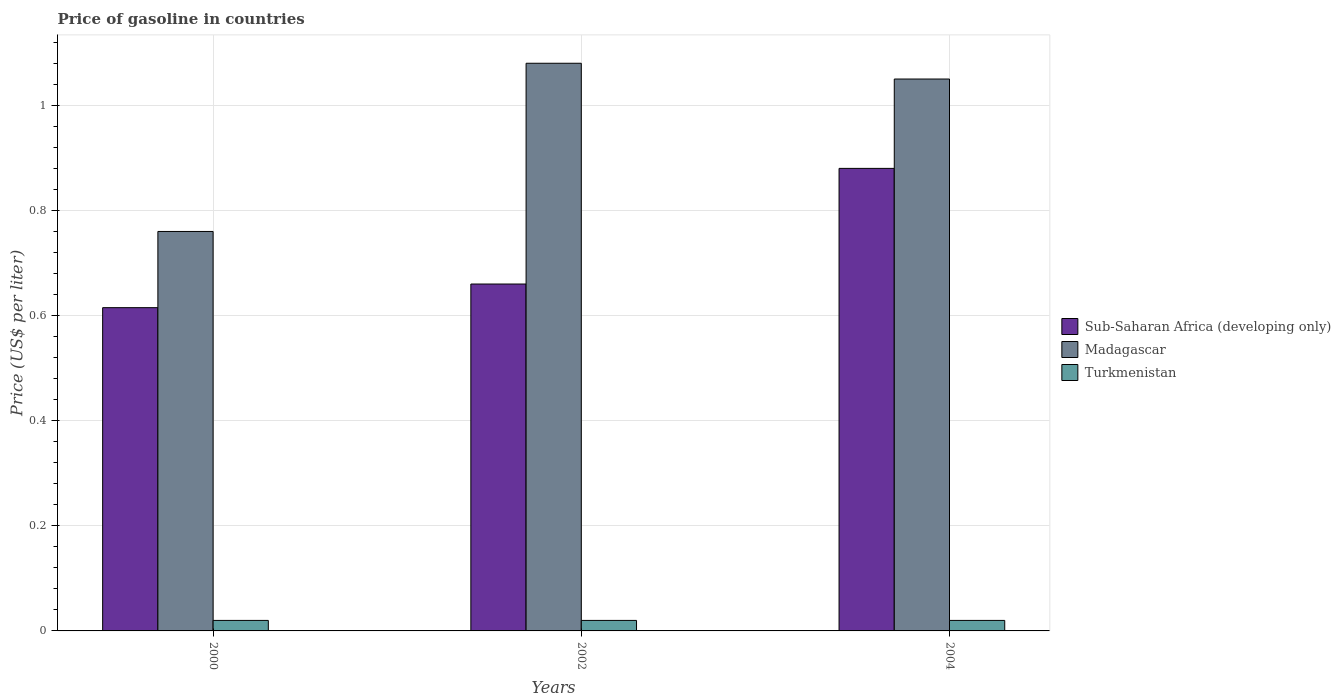How many groups of bars are there?
Offer a terse response. 3. Are the number of bars per tick equal to the number of legend labels?
Offer a terse response. Yes. How many bars are there on the 2nd tick from the left?
Offer a terse response. 3. How many bars are there on the 3rd tick from the right?
Offer a very short reply. 3. What is the label of the 2nd group of bars from the left?
Your answer should be compact. 2002. In how many cases, is the number of bars for a given year not equal to the number of legend labels?
Provide a short and direct response. 0. What is the price of gasoline in Sub-Saharan Africa (developing only) in 2002?
Your response must be concise. 0.66. Across all years, what is the maximum price of gasoline in Sub-Saharan Africa (developing only)?
Provide a short and direct response. 0.88. Across all years, what is the minimum price of gasoline in Turkmenistan?
Your answer should be compact. 0.02. What is the difference between the price of gasoline in Sub-Saharan Africa (developing only) in 2000 and that in 2002?
Provide a short and direct response. -0.05. What is the difference between the price of gasoline in Madagascar in 2002 and the price of gasoline in Sub-Saharan Africa (developing only) in 2004?
Offer a terse response. 0.2. What is the average price of gasoline in Turkmenistan per year?
Ensure brevity in your answer.  0.02. In the year 2002, what is the difference between the price of gasoline in Turkmenistan and price of gasoline in Sub-Saharan Africa (developing only)?
Give a very brief answer. -0.64. In how many years, is the price of gasoline in Turkmenistan greater than 1 US$?
Make the answer very short. 0. What is the ratio of the price of gasoline in Madagascar in 2000 to that in 2002?
Offer a terse response. 0.7. Is the difference between the price of gasoline in Turkmenistan in 2000 and 2004 greater than the difference between the price of gasoline in Sub-Saharan Africa (developing only) in 2000 and 2004?
Your answer should be compact. Yes. What is the difference between the highest and the second highest price of gasoline in Turkmenistan?
Give a very brief answer. 0. What is the difference between the highest and the lowest price of gasoline in Madagascar?
Offer a terse response. 0.32. In how many years, is the price of gasoline in Turkmenistan greater than the average price of gasoline in Turkmenistan taken over all years?
Give a very brief answer. 0. Is the sum of the price of gasoline in Madagascar in 2002 and 2004 greater than the maximum price of gasoline in Sub-Saharan Africa (developing only) across all years?
Give a very brief answer. Yes. What does the 2nd bar from the left in 2002 represents?
Provide a short and direct response. Madagascar. What does the 2nd bar from the right in 2004 represents?
Your response must be concise. Madagascar. Is it the case that in every year, the sum of the price of gasoline in Turkmenistan and price of gasoline in Madagascar is greater than the price of gasoline in Sub-Saharan Africa (developing only)?
Make the answer very short. Yes. Are all the bars in the graph horizontal?
Your response must be concise. No. Does the graph contain any zero values?
Give a very brief answer. No. Does the graph contain grids?
Give a very brief answer. Yes. What is the title of the graph?
Make the answer very short. Price of gasoline in countries. What is the label or title of the X-axis?
Provide a short and direct response. Years. What is the label or title of the Y-axis?
Keep it short and to the point. Price (US$ per liter). What is the Price (US$ per liter) in Sub-Saharan Africa (developing only) in 2000?
Your answer should be very brief. 0.61. What is the Price (US$ per liter) of Madagascar in 2000?
Ensure brevity in your answer.  0.76. What is the Price (US$ per liter) in Sub-Saharan Africa (developing only) in 2002?
Offer a terse response. 0.66. What is the Price (US$ per liter) in Madagascar in 2002?
Keep it short and to the point. 1.08. What is the Price (US$ per liter) of Turkmenistan in 2002?
Provide a short and direct response. 0.02. What is the Price (US$ per liter) of Sub-Saharan Africa (developing only) in 2004?
Provide a short and direct response. 0.88. What is the Price (US$ per liter) of Madagascar in 2004?
Offer a very short reply. 1.05. What is the Price (US$ per liter) of Turkmenistan in 2004?
Provide a short and direct response. 0.02. Across all years, what is the minimum Price (US$ per liter) of Sub-Saharan Africa (developing only)?
Make the answer very short. 0.61. Across all years, what is the minimum Price (US$ per liter) in Madagascar?
Offer a very short reply. 0.76. Across all years, what is the minimum Price (US$ per liter) in Turkmenistan?
Your answer should be very brief. 0.02. What is the total Price (US$ per liter) in Sub-Saharan Africa (developing only) in the graph?
Provide a succinct answer. 2.15. What is the total Price (US$ per liter) in Madagascar in the graph?
Provide a short and direct response. 2.89. What is the total Price (US$ per liter) in Turkmenistan in the graph?
Make the answer very short. 0.06. What is the difference between the Price (US$ per liter) of Sub-Saharan Africa (developing only) in 2000 and that in 2002?
Offer a very short reply. -0.04. What is the difference between the Price (US$ per liter) in Madagascar in 2000 and that in 2002?
Ensure brevity in your answer.  -0.32. What is the difference between the Price (US$ per liter) in Sub-Saharan Africa (developing only) in 2000 and that in 2004?
Give a very brief answer. -0.27. What is the difference between the Price (US$ per liter) in Madagascar in 2000 and that in 2004?
Your answer should be compact. -0.29. What is the difference between the Price (US$ per liter) in Turkmenistan in 2000 and that in 2004?
Make the answer very short. 0. What is the difference between the Price (US$ per liter) of Sub-Saharan Africa (developing only) in 2002 and that in 2004?
Provide a succinct answer. -0.22. What is the difference between the Price (US$ per liter) in Madagascar in 2002 and that in 2004?
Give a very brief answer. 0.03. What is the difference between the Price (US$ per liter) in Turkmenistan in 2002 and that in 2004?
Offer a very short reply. 0. What is the difference between the Price (US$ per liter) in Sub-Saharan Africa (developing only) in 2000 and the Price (US$ per liter) in Madagascar in 2002?
Make the answer very short. -0.47. What is the difference between the Price (US$ per liter) of Sub-Saharan Africa (developing only) in 2000 and the Price (US$ per liter) of Turkmenistan in 2002?
Give a very brief answer. 0.59. What is the difference between the Price (US$ per liter) of Madagascar in 2000 and the Price (US$ per liter) of Turkmenistan in 2002?
Provide a succinct answer. 0.74. What is the difference between the Price (US$ per liter) in Sub-Saharan Africa (developing only) in 2000 and the Price (US$ per liter) in Madagascar in 2004?
Offer a very short reply. -0.43. What is the difference between the Price (US$ per liter) in Sub-Saharan Africa (developing only) in 2000 and the Price (US$ per liter) in Turkmenistan in 2004?
Give a very brief answer. 0.59. What is the difference between the Price (US$ per liter) of Madagascar in 2000 and the Price (US$ per liter) of Turkmenistan in 2004?
Offer a terse response. 0.74. What is the difference between the Price (US$ per liter) in Sub-Saharan Africa (developing only) in 2002 and the Price (US$ per liter) in Madagascar in 2004?
Ensure brevity in your answer.  -0.39. What is the difference between the Price (US$ per liter) in Sub-Saharan Africa (developing only) in 2002 and the Price (US$ per liter) in Turkmenistan in 2004?
Make the answer very short. 0.64. What is the difference between the Price (US$ per liter) in Madagascar in 2002 and the Price (US$ per liter) in Turkmenistan in 2004?
Your answer should be very brief. 1.06. What is the average Price (US$ per liter) in Sub-Saharan Africa (developing only) per year?
Your answer should be very brief. 0.72. What is the average Price (US$ per liter) in Madagascar per year?
Provide a short and direct response. 0.96. What is the average Price (US$ per liter) in Turkmenistan per year?
Provide a succinct answer. 0.02. In the year 2000, what is the difference between the Price (US$ per liter) of Sub-Saharan Africa (developing only) and Price (US$ per liter) of Madagascar?
Offer a terse response. -0.14. In the year 2000, what is the difference between the Price (US$ per liter) of Sub-Saharan Africa (developing only) and Price (US$ per liter) of Turkmenistan?
Give a very brief answer. 0.59. In the year 2000, what is the difference between the Price (US$ per liter) of Madagascar and Price (US$ per liter) of Turkmenistan?
Your response must be concise. 0.74. In the year 2002, what is the difference between the Price (US$ per liter) of Sub-Saharan Africa (developing only) and Price (US$ per liter) of Madagascar?
Give a very brief answer. -0.42. In the year 2002, what is the difference between the Price (US$ per liter) in Sub-Saharan Africa (developing only) and Price (US$ per liter) in Turkmenistan?
Provide a short and direct response. 0.64. In the year 2002, what is the difference between the Price (US$ per liter) in Madagascar and Price (US$ per liter) in Turkmenistan?
Offer a very short reply. 1.06. In the year 2004, what is the difference between the Price (US$ per liter) in Sub-Saharan Africa (developing only) and Price (US$ per liter) in Madagascar?
Make the answer very short. -0.17. In the year 2004, what is the difference between the Price (US$ per liter) in Sub-Saharan Africa (developing only) and Price (US$ per liter) in Turkmenistan?
Keep it short and to the point. 0.86. In the year 2004, what is the difference between the Price (US$ per liter) of Madagascar and Price (US$ per liter) of Turkmenistan?
Provide a short and direct response. 1.03. What is the ratio of the Price (US$ per liter) of Sub-Saharan Africa (developing only) in 2000 to that in 2002?
Your answer should be compact. 0.93. What is the ratio of the Price (US$ per liter) in Madagascar in 2000 to that in 2002?
Give a very brief answer. 0.7. What is the ratio of the Price (US$ per liter) of Turkmenistan in 2000 to that in 2002?
Your answer should be very brief. 1. What is the ratio of the Price (US$ per liter) in Sub-Saharan Africa (developing only) in 2000 to that in 2004?
Provide a short and direct response. 0.7. What is the ratio of the Price (US$ per liter) in Madagascar in 2000 to that in 2004?
Ensure brevity in your answer.  0.72. What is the ratio of the Price (US$ per liter) of Sub-Saharan Africa (developing only) in 2002 to that in 2004?
Your response must be concise. 0.75. What is the ratio of the Price (US$ per liter) of Madagascar in 2002 to that in 2004?
Make the answer very short. 1.03. What is the ratio of the Price (US$ per liter) in Turkmenistan in 2002 to that in 2004?
Your answer should be very brief. 1. What is the difference between the highest and the second highest Price (US$ per liter) in Sub-Saharan Africa (developing only)?
Provide a succinct answer. 0.22. What is the difference between the highest and the lowest Price (US$ per liter) in Sub-Saharan Africa (developing only)?
Ensure brevity in your answer.  0.27. What is the difference between the highest and the lowest Price (US$ per liter) in Madagascar?
Your response must be concise. 0.32. 